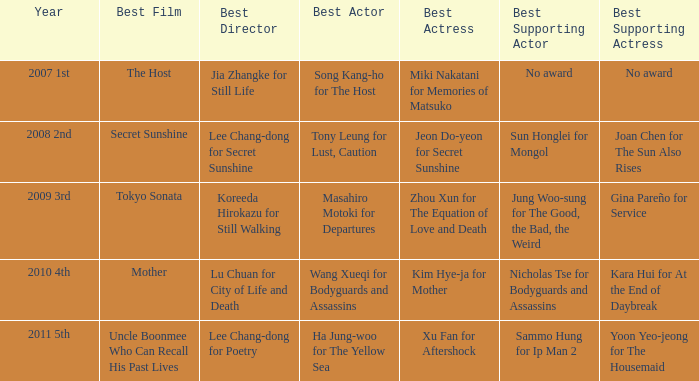Who is the foremost director for mother? Lu Chuan for City of Life and Death. 